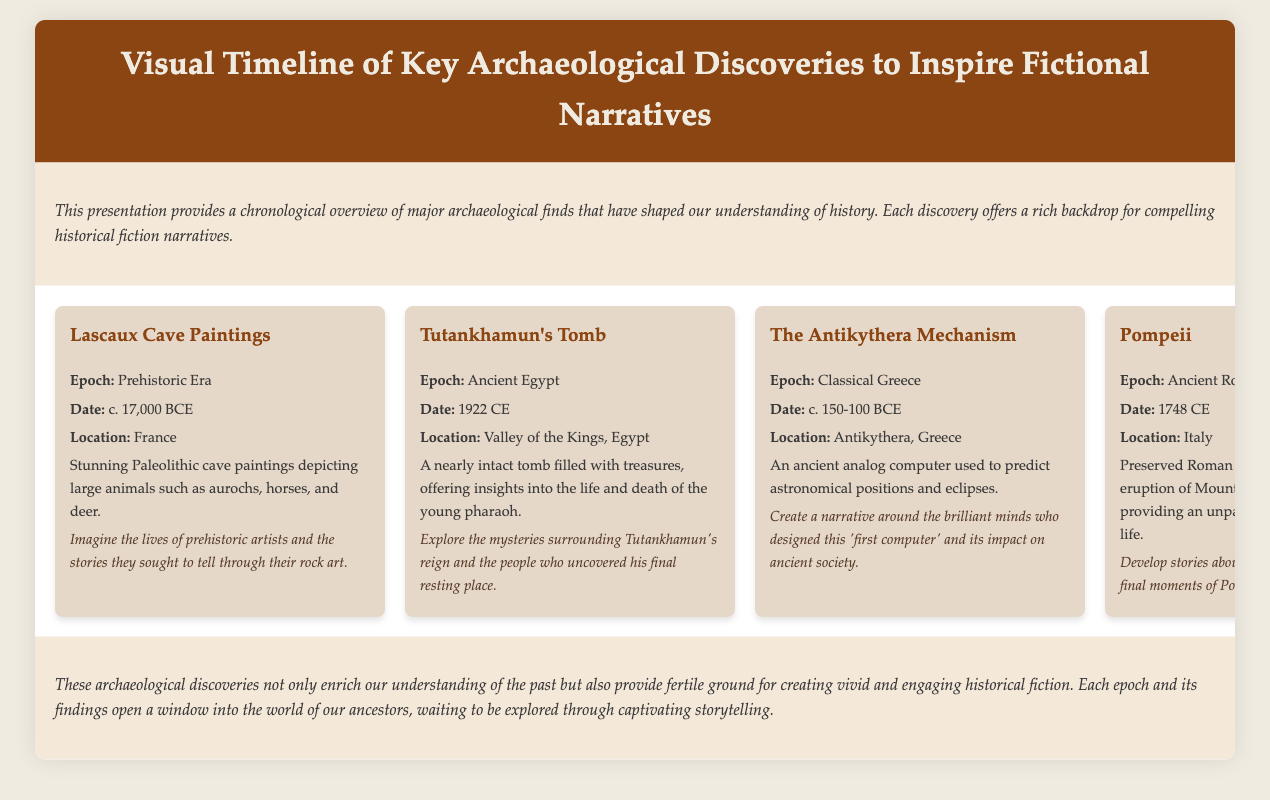What year were the Lascaux Cave Paintings created? The Lascaux Cave Paintings were created around 17,000 BCE, as stated in the document.
Answer: 17,000 BCE Where was Tutankhamun's Tomb located? The location of Tutankhamun's Tomb is mentioned as the Valley of the Kings, Egypt.
Answer: Valley of the Kings, Egypt What ancient artifact is known as the 'first computer'? The Antikythera Mechanism is referred to as the 'first computer' in the document.
Answer: Antikythera Mechanism Which archaeological find offers a snapshot of Roman life? The document mentions Pompeii as providing an unparalleled snapshot of Roman life.
Answer: Pompeii What is a significant theme for storytelling inspired by Sutton Hoo Ship Burial? The document suggests exploring the lore of Anglo-Saxon warriors and kings as a significant theme.
Answer: Anglo-Saxon warriors How many terracotta soldiers were found with Qin Shi Huang? More than 8,000 life-sized terracotta soldiers were discovered, as stated in the document.
Answer: 8,000 What epoch does Machu Picchu belong to? The epoch of Machu Picchu is identified as Pre-Columbian Americas in the document.
Answer: Pre-Columbian Americas What is the primary purpose of the presentation? The primary purpose is to provide a chronological overview of major archaeological finds that inspire historical fiction narratives.
Answer: Inspire historical fiction narratives 